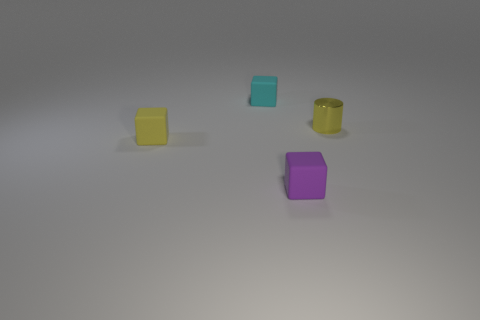Add 4 yellow rubber cubes. How many objects exist? 8 Subtract all blocks. How many objects are left? 1 Subtract all tiny yellow cubes. Subtract all yellow things. How many objects are left? 1 Add 2 tiny yellow rubber things. How many tiny yellow rubber things are left? 3 Add 3 large green rubber cylinders. How many large green rubber cylinders exist? 3 Subtract 1 purple blocks. How many objects are left? 3 